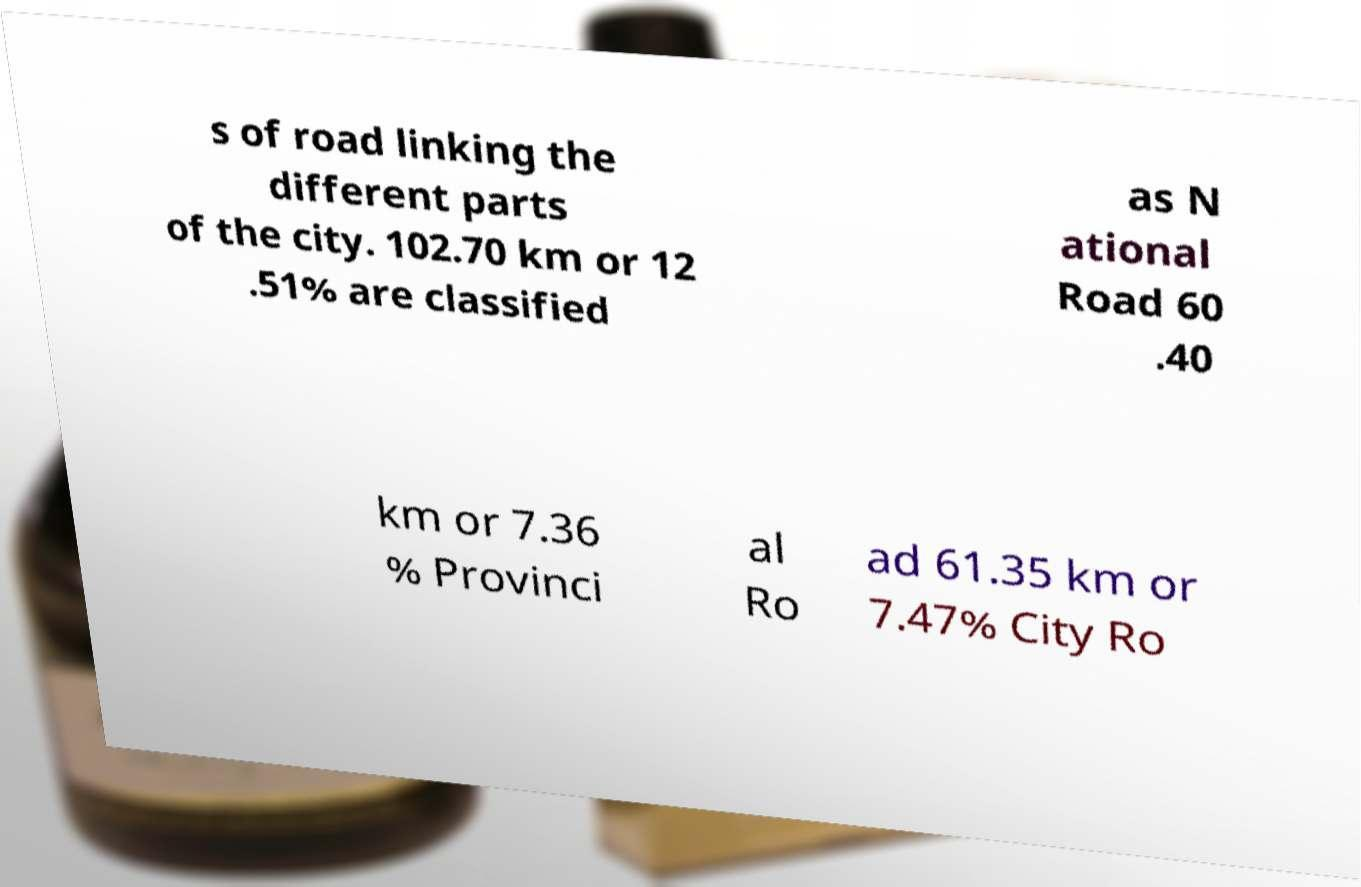Please identify and transcribe the text found in this image. s of road linking the different parts of the city. 102.70 km or 12 .51% are classified as N ational Road 60 .40 km or 7.36 % Provinci al Ro ad 61.35 km or 7.47% City Ro 